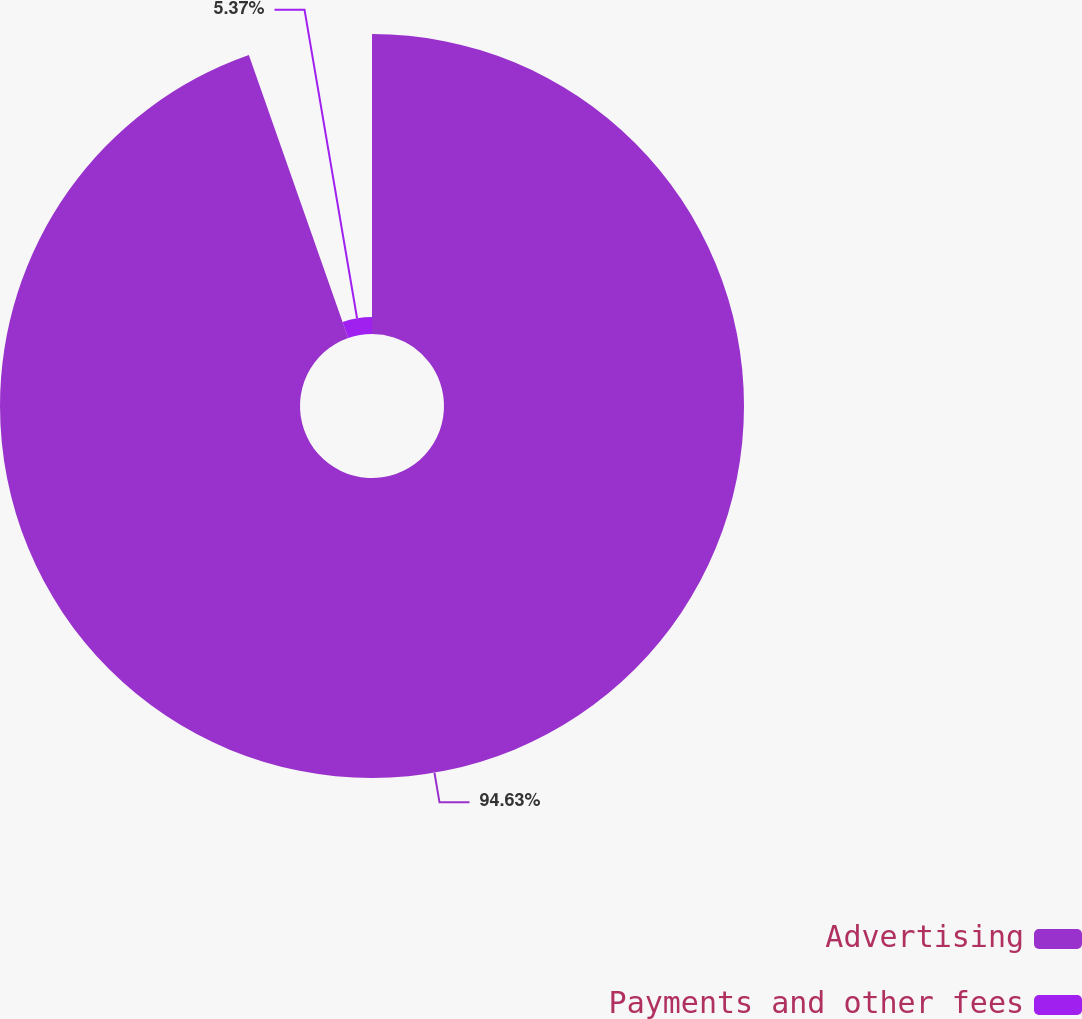Convert chart. <chart><loc_0><loc_0><loc_500><loc_500><pie_chart><fcel>Advertising<fcel>Payments and other fees<nl><fcel>94.63%<fcel>5.37%<nl></chart> 